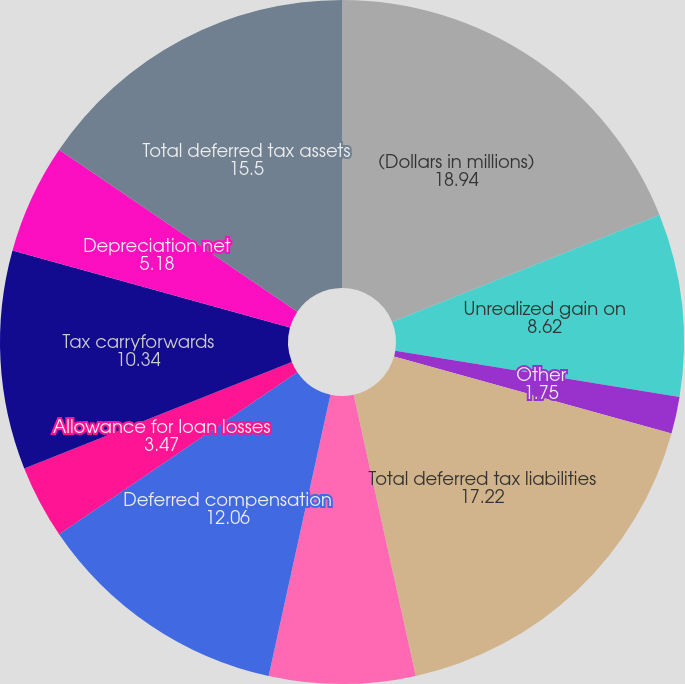Convert chart to OTSL. <chart><loc_0><loc_0><loc_500><loc_500><pie_chart><fcel>(Dollars in millions)<fcel>Unrealized gain on<fcel>Other<fcel>Total deferred tax liabilities<fcel>Operating expenses not<fcel>Deferred compensation<fcel>Allowance for loan losses<fcel>Tax carryforwards<fcel>Depreciation net<fcel>Total deferred tax assets<nl><fcel>18.94%<fcel>8.62%<fcel>1.75%<fcel>17.22%<fcel>6.9%<fcel>12.06%<fcel>3.47%<fcel>10.34%<fcel>5.18%<fcel>15.5%<nl></chart> 